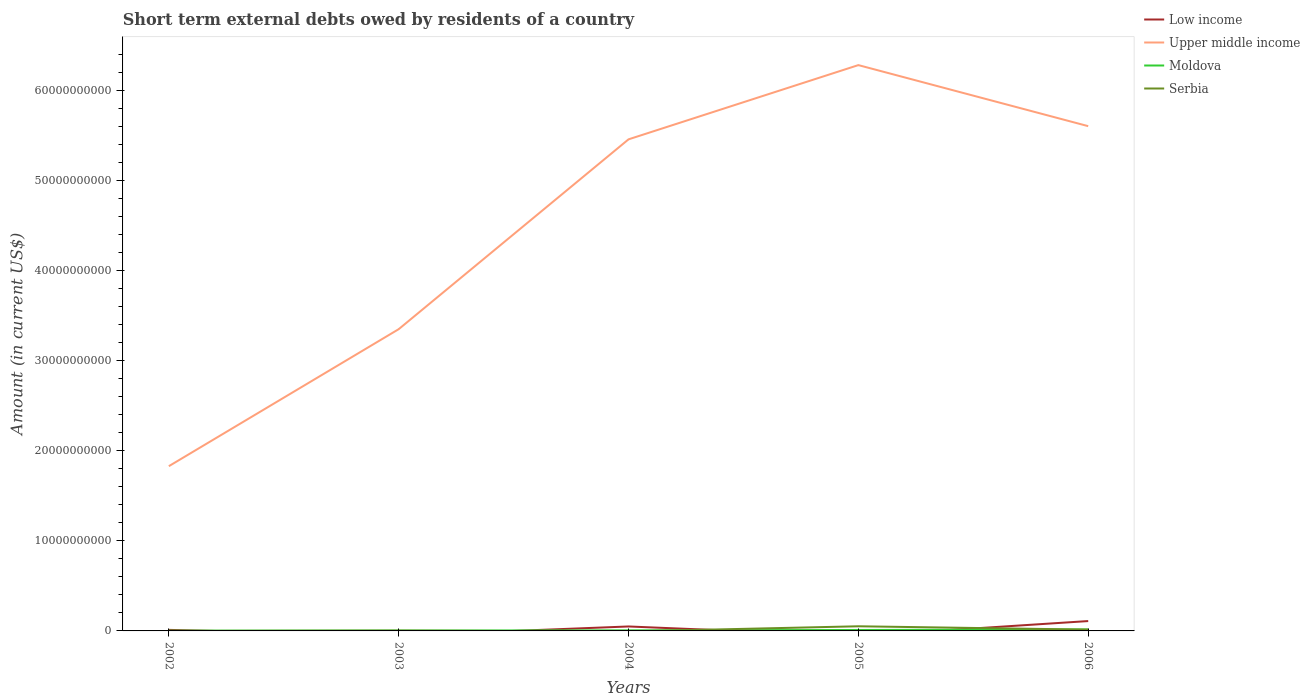How many different coloured lines are there?
Your answer should be compact. 4. Across all years, what is the maximum amount of short-term external debts owed by residents in Low income?
Ensure brevity in your answer.  0. What is the total amount of short-term external debts owed by residents in Low income in the graph?
Keep it short and to the point. -3.78e+08. What is the difference between the highest and the second highest amount of short-term external debts owed by residents in Moldova?
Your answer should be compact. 1.36e+08. What is the difference between the highest and the lowest amount of short-term external debts owed by residents in Moldova?
Give a very brief answer. 2. What is the difference between two consecutive major ticks on the Y-axis?
Your response must be concise. 1.00e+1. How many legend labels are there?
Keep it short and to the point. 4. What is the title of the graph?
Ensure brevity in your answer.  Short term external debts owed by residents of a country. Does "China" appear as one of the legend labels in the graph?
Your response must be concise. No. What is the label or title of the Y-axis?
Your response must be concise. Amount (in current US$). What is the Amount (in current US$) of Low income in 2002?
Ensure brevity in your answer.  1.17e+08. What is the Amount (in current US$) in Upper middle income in 2002?
Keep it short and to the point. 1.83e+1. What is the Amount (in current US$) of Moldova in 2002?
Offer a terse response. 2.94e+07. What is the Amount (in current US$) of Upper middle income in 2003?
Provide a short and direct response. 3.35e+1. What is the Amount (in current US$) in Moldova in 2003?
Give a very brief answer. 4.30e+07. What is the Amount (in current US$) of Serbia in 2003?
Give a very brief answer. 3.55e+07. What is the Amount (in current US$) of Low income in 2004?
Make the answer very short. 4.95e+08. What is the Amount (in current US$) of Upper middle income in 2004?
Give a very brief answer. 5.46e+1. What is the Amount (in current US$) of Moldova in 2004?
Your answer should be compact. 6.33e+07. What is the Amount (in current US$) of Serbia in 2004?
Make the answer very short. 0. What is the Amount (in current US$) of Low income in 2005?
Offer a terse response. 0. What is the Amount (in current US$) of Upper middle income in 2005?
Your response must be concise. 6.28e+1. What is the Amount (in current US$) of Moldova in 2005?
Make the answer very short. 1.04e+08. What is the Amount (in current US$) in Serbia in 2005?
Your response must be concise. 5.15e+08. What is the Amount (in current US$) of Low income in 2006?
Keep it short and to the point. 1.09e+09. What is the Amount (in current US$) of Upper middle income in 2006?
Provide a succinct answer. 5.60e+1. What is the Amount (in current US$) of Moldova in 2006?
Provide a succinct answer. 1.65e+08. What is the Amount (in current US$) in Serbia in 2006?
Provide a short and direct response. 1.43e+08. Across all years, what is the maximum Amount (in current US$) of Low income?
Make the answer very short. 1.09e+09. Across all years, what is the maximum Amount (in current US$) in Upper middle income?
Your answer should be compact. 6.28e+1. Across all years, what is the maximum Amount (in current US$) of Moldova?
Make the answer very short. 1.65e+08. Across all years, what is the maximum Amount (in current US$) of Serbia?
Keep it short and to the point. 5.15e+08. Across all years, what is the minimum Amount (in current US$) of Upper middle income?
Give a very brief answer. 1.83e+1. Across all years, what is the minimum Amount (in current US$) of Moldova?
Provide a succinct answer. 2.94e+07. What is the total Amount (in current US$) of Low income in the graph?
Keep it short and to the point. 1.71e+09. What is the total Amount (in current US$) of Upper middle income in the graph?
Ensure brevity in your answer.  2.25e+11. What is the total Amount (in current US$) in Moldova in the graph?
Offer a terse response. 4.05e+08. What is the total Amount (in current US$) in Serbia in the graph?
Offer a very short reply. 6.94e+08. What is the difference between the Amount (in current US$) of Upper middle income in 2002 and that in 2003?
Offer a very short reply. -1.52e+1. What is the difference between the Amount (in current US$) of Moldova in 2002 and that in 2003?
Your response must be concise. -1.35e+07. What is the difference between the Amount (in current US$) in Low income in 2002 and that in 2004?
Offer a terse response. -3.78e+08. What is the difference between the Amount (in current US$) in Upper middle income in 2002 and that in 2004?
Your answer should be compact. -3.63e+1. What is the difference between the Amount (in current US$) in Moldova in 2002 and that in 2004?
Your answer should be very brief. -3.39e+07. What is the difference between the Amount (in current US$) in Upper middle income in 2002 and that in 2005?
Your response must be concise. -4.45e+1. What is the difference between the Amount (in current US$) of Moldova in 2002 and that in 2005?
Offer a terse response. -7.43e+07. What is the difference between the Amount (in current US$) in Low income in 2002 and that in 2006?
Provide a succinct answer. -9.78e+08. What is the difference between the Amount (in current US$) in Upper middle income in 2002 and that in 2006?
Your answer should be compact. -3.77e+1. What is the difference between the Amount (in current US$) in Moldova in 2002 and that in 2006?
Offer a terse response. -1.36e+08. What is the difference between the Amount (in current US$) in Upper middle income in 2003 and that in 2004?
Your response must be concise. -2.11e+1. What is the difference between the Amount (in current US$) in Moldova in 2003 and that in 2004?
Your response must be concise. -2.04e+07. What is the difference between the Amount (in current US$) of Upper middle income in 2003 and that in 2005?
Provide a succinct answer. -2.93e+1. What is the difference between the Amount (in current US$) in Moldova in 2003 and that in 2005?
Your response must be concise. -6.08e+07. What is the difference between the Amount (in current US$) of Serbia in 2003 and that in 2005?
Make the answer very short. -4.80e+08. What is the difference between the Amount (in current US$) of Upper middle income in 2003 and that in 2006?
Your answer should be very brief. -2.25e+1. What is the difference between the Amount (in current US$) in Moldova in 2003 and that in 2006?
Offer a very short reply. -1.22e+08. What is the difference between the Amount (in current US$) of Serbia in 2003 and that in 2006?
Your answer should be compact. -1.08e+08. What is the difference between the Amount (in current US$) in Upper middle income in 2004 and that in 2005?
Ensure brevity in your answer.  -8.24e+09. What is the difference between the Amount (in current US$) of Moldova in 2004 and that in 2005?
Provide a short and direct response. -4.04e+07. What is the difference between the Amount (in current US$) in Low income in 2004 and that in 2006?
Your response must be concise. -6.00e+08. What is the difference between the Amount (in current US$) in Upper middle income in 2004 and that in 2006?
Provide a succinct answer. -1.46e+09. What is the difference between the Amount (in current US$) in Moldova in 2004 and that in 2006?
Your response must be concise. -1.02e+08. What is the difference between the Amount (in current US$) of Upper middle income in 2005 and that in 2006?
Keep it short and to the point. 6.78e+09. What is the difference between the Amount (in current US$) of Moldova in 2005 and that in 2006?
Offer a very short reply. -6.16e+07. What is the difference between the Amount (in current US$) in Serbia in 2005 and that in 2006?
Provide a short and direct response. 3.72e+08. What is the difference between the Amount (in current US$) in Low income in 2002 and the Amount (in current US$) in Upper middle income in 2003?
Keep it short and to the point. -3.34e+1. What is the difference between the Amount (in current US$) in Low income in 2002 and the Amount (in current US$) in Moldova in 2003?
Your response must be concise. 7.38e+07. What is the difference between the Amount (in current US$) in Low income in 2002 and the Amount (in current US$) in Serbia in 2003?
Offer a very short reply. 8.13e+07. What is the difference between the Amount (in current US$) of Upper middle income in 2002 and the Amount (in current US$) of Moldova in 2003?
Ensure brevity in your answer.  1.82e+1. What is the difference between the Amount (in current US$) in Upper middle income in 2002 and the Amount (in current US$) in Serbia in 2003?
Give a very brief answer. 1.83e+1. What is the difference between the Amount (in current US$) of Moldova in 2002 and the Amount (in current US$) of Serbia in 2003?
Provide a succinct answer. -6.06e+06. What is the difference between the Amount (in current US$) of Low income in 2002 and the Amount (in current US$) of Upper middle income in 2004?
Ensure brevity in your answer.  -5.45e+1. What is the difference between the Amount (in current US$) of Low income in 2002 and the Amount (in current US$) of Moldova in 2004?
Provide a succinct answer. 5.35e+07. What is the difference between the Amount (in current US$) in Upper middle income in 2002 and the Amount (in current US$) in Moldova in 2004?
Your response must be concise. 1.82e+1. What is the difference between the Amount (in current US$) of Low income in 2002 and the Amount (in current US$) of Upper middle income in 2005?
Make the answer very short. -6.27e+1. What is the difference between the Amount (in current US$) of Low income in 2002 and the Amount (in current US$) of Moldova in 2005?
Make the answer very short. 1.30e+07. What is the difference between the Amount (in current US$) of Low income in 2002 and the Amount (in current US$) of Serbia in 2005?
Provide a short and direct response. -3.99e+08. What is the difference between the Amount (in current US$) in Upper middle income in 2002 and the Amount (in current US$) in Moldova in 2005?
Give a very brief answer. 1.82e+1. What is the difference between the Amount (in current US$) of Upper middle income in 2002 and the Amount (in current US$) of Serbia in 2005?
Your answer should be very brief. 1.78e+1. What is the difference between the Amount (in current US$) in Moldova in 2002 and the Amount (in current US$) in Serbia in 2005?
Provide a short and direct response. -4.86e+08. What is the difference between the Amount (in current US$) in Low income in 2002 and the Amount (in current US$) in Upper middle income in 2006?
Offer a very short reply. -5.59e+1. What is the difference between the Amount (in current US$) of Low income in 2002 and the Amount (in current US$) of Moldova in 2006?
Provide a succinct answer. -4.86e+07. What is the difference between the Amount (in current US$) in Low income in 2002 and the Amount (in current US$) in Serbia in 2006?
Make the answer very short. -2.64e+07. What is the difference between the Amount (in current US$) in Upper middle income in 2002 and the Amount (in current US$) in Moldova in 2006?
Your answer should be compact. 1.81e+1. What is the difference between the Amount (in current US$) of Upper middle income in 2002 and the Amount (in current US$) of Serbia in 2006?
Your answer should be very brief. 1.81e+1. What is the difference between the Amount (in current US$) in Moldova in 2002 and the Amount (in current US$) in Serbia in 2006?
Your response must be concise. -1.14e+08. What is the difference between the Amount (in current US$) in Upper middle income in 2003 and the Amount (in current US$) in Moldova in 2004?
Offer a terse response. 3.34e+1. What is the difference between the Amount (in current US$) in Upper middle income in 2003 and the Amount (in current US$) in Moldova in 2005?
Provide a succinct answer. 3.34e+1. What is the difference between the Amount (in current US$) in Upper middle income in 2003 and the Amount (in current US$) in Serbia in 2005?
Your answer should be compact. 3.30e+1. What is the difference between the Amount (in current US$) of Moldova in 2003 and the Amount (in current US$) of Serbia in 2005?
Your answer should be compact. -4.72e+08. What is the difference between the Amount (in current US$) of Upper middle income in 2003 and the Amount (in current US$) of Moldova in 2006?
Offer a terse response. 3.33e+1. What is the difference between the Amount (in current US$) in Upper middle income in 2003 and the Amount (in current US$) in Serbia in 2006?
Provide a short and direct response. 3.34e+1. What is the difference between the Amount (in current US$) of Moldova in 2003 and the Amount (in current US$) of Serbia in 2006?
Give a very brief answer. -1.00e+08. What is the difference between the Amount (in current US$) of Low income in 2004 and the Amount (in current US$) of Upper middle income in 2005?
Your answer should be compact. -6.23e+1. What is the difference between the Amount (in current US$) in Low income in 2004 and the Amount (in current US$) in Moldova in 2005?
Ensure brevity in your answer.  3.91e+08. What is the difference between the Amount (in current US$) in Low income in 2004 and the Amount (in current US$) in Serbia in 2005?
Keep it short and to the point. -2.09e+07. What is the difference between the Amount (in current US$) of Upper middle income in 2004 and the Amount (in current US$) of Moldova in 2005?
Offer a terse response. 5.45e+1. What is the difference between the Amount (in current US$) in Upper middle income in 2004 and the Amount (in current US$) in Serbia in 2005?
Your answer should be very brief. 5.41e+1. What is the difference between the Amount (in current US$) of Moldova in 2004 and the Amount (in current US$) of Serbia in 2005?
Give a very brief answer. -4.52e+08. What is the difference between the Amount (in current US$) of Low income in 2004 and the Amount (in current US$) of Upper middle income in 2006?
Keep it short and to the point. -5.55e+1. What is the difference between the Amount (in current US$) in Low income in 2004 and the Amount (in current US$) in Moldova in 2006?
Your answer should be compact. 3.29e+08. What is the difference between the Amount (in current US$) of Low income in 2004 and the Amount (in current US$) of Serbia in 2006?
Provide a succinct answer. 3.51e+08. What is the difference between the Amount (in current US$) in Upper middle income in 2004 and the Amount (in current US$) in Moldova in 2006?
Ensure brevity in your answer.  5.44e+1. What is the difference between the Amount (in current US$) of Upper middle income in 2004 and the Amount (in current US$) of Serbia in 2006?
Ensure brevity in your answer.  5.44e+1. What is the difference between the Amount (in current US$) in Moldova in 2004 and the Amount (in current US$) in Serbia in 2006?
Offer a terse response. -7.99e+07. What is the difference between the Amount (in current US$) of Upper middle income in 2005 and the Amount (in current US$) of Moldova in 2006?
Keep it short and to the point. 6.26e+1. What is the difference between the Amount (in current US$) in Upper middle income in 2005 and the Amount (in current US$) in Serbia in 2006?
Your answer should be very brief. 6.27e+1. What is the difference between the Amount (in current US$) in Moldova in 2005 and the Amount (in current US$) in Serbia in 2006?
Your answer should be very brief. -3.95e+07. What is the average Amount (in current US$) of Low income per year?
Offer a very short reply. 3.41e+08. What is the average Amount (in current US$) of Upper middle income per year?
Provide a succinct answer. 4.50e+1. What is the average Amount (in current US$) of Moldova per year?
Your answer should be very brief. 8.10e+07. What is the average Amount (in current US$) in Serbia per year?
Your response must be concise. 1.39e+08. In the year 2002, what is the difference between the Amount (in current US$) of Low income and Amount (in current US$) of Upper middle income?
Your answer should be very brief. -1.82e+1. In the year 2002, what is the difference between the Amount (in current US$) of Low income and Amount (in current US$) of Moldova?
Give a very brief answer. 8.73e+07. In the year 2002, what is the difference between the Amount (in current US$) in Upper middle income and Amount (in current US$) in Moldova?
Ensure brevity in your answer.  1.83e+1. In the year 2003, what is the difference between the Amount (in current US$) in Upper middle income and Amount (in current US$) in Moldova?
Make the answer very short. 3.35e+1. In the year 2003, what is the difference between the Amount (in current US$) in Upper middle income and Amount (in current US$) in Serbia?
Your answer should be very brief. 3.35e+1. In the year 2003, what is the difference between the Amount (in current US$) in Moldova and Amount (in current US$) in Serbia?
Offer a terse response. 7.46e+06. In the year 2004, what is the difference between the Amount (in current US$) in Low income and Amount (in current US$) in Upper middle income?
Offer a terse response. -5.41e+1. In the year 2004, what is the difference between the Amount (in current US$) of Low income and Amount (in current US$) of Moldova?
Provide a succinct answer. 4.31e+08. In the year 2004, what is the difference between the Amount (in current US$) in Upper middle income and Amount (in current US$) in Moldova?
Offer a terse response. 5.45e+1. In the year 2005, what is the difference between the Amount (in current US$) of Upper middle income and Amount (in current US$) of Moldova?
Give a very brief answer. 6.27e+1. In the year 2005, what is the difference between the Amount (in current US$) of Upper middle income and Amount (in current US$) of Serbia?
Make the answer very short. 6.23e+1. In the year 2005, what is the difference between the Amount (in current US$) in Moldova and Amount (in current US$) in Serbia?
Ensure brevity in your answer.  -4.12e+08. In the year 2006, what is the difference between the Amount (in current US$) in Low income and Amount (in current US$) in Upper middle income?
Your answer should be compact. -5.49e+1. In the year 2006, what is the difference between the Amount (in current US$) of Low income and Amount (in current US$) of Moldova?
Keep it short and to the point. 9.29e+08. In the year 2006, what is the difference between the Amount (in current US$) in Low income and Amount (in current US$) in Serbia?
Give a very brief answer. 9.52e+08. In the year 2006, what is the difference between the Amount (in current US$) of Upper middle income and Amount (in current US$) of Moldova?
Your answer should be compact. 5.59e+1. In the year 2006, what is the difference between the Amount (in current US$) of Upper middle income and Amount (in current US$) of Serbia?
Offer a very short reply. 5.59e+1. In the year 2006, what is the difference between the Amount (in current US$) of Moldova and Amount (in current US$) of Serbia?
Ensure brevity in your answer.  2.22e+07. What is the ratio of the Amount (in current US$) in Upper middle income in 2002 to that in 2003?
Ensure brevity in your answer.  0.55. What is the ratio of the Amount (in current US$) in Moldova in 2002 to that in 2003?
Keep it short and to the point. 0.69. What is the ratio of the Amount (in current US$) of Low income in 2002 to that in 2004?
Make the answer very short. 0.24. What is the ratio of the Amount (in current US$) in Upper middle income in 2002 to that in 2004?
Provide a succinct answer. 0.34. What is the ratio of the Amount (in current US$) in Moldova in 2002 to that in 2004?
Your answer should be very brief. 0.47. What is the ratio of the Amount (in current US$) in Upper middle income in 2002 to that in 2005?
Your response must be concise. 0.29. What is the ratio of the Amount (in current US$) of Moldova in 2002 to that in 2005?
Give a very brief answer. 0.28. What is the ratio of the Amount (in current US$) in Low income in 2002 to that in 2006?
Your answer should be compact. 0.11. What is the ratio of the Amount (in current US$) in Upper middle income in 2002 to that in 2006?
Offer a terse response. 0.33. What is the ratio of the Amount (in current US$) of Moldova in 2002 to that in 2006?
Your answer should be very brief. 0.18. What is the ratio of the Amount (in current US$) of Upper middle income in 2003 to that in 2004?
Offer a very short reply. 0.61. What is the ratio of the Amount (in current US$) of Moldova in 2003 to that in 2004?
Give a very brief answer. 0.68. What is the ratio of the Amount (in current US$) of Upper middle income in 2003 to that in 2005?
Offer a terse response. 0.53. What is the ratio of the Amount (in current US$) of Moldova in 2003 to that in 2005?
Offer a very short reply. 0.41. What is the ratio of the Amount (in current US$) of Serbia in 2003 to that in 2005?
Ensure brevity in your answer.  0.07. What is the ratio of the Amount (in current US$) in Upper middle income in 2003 to that in 2006?
Your answer should be very brief. 0.6. What is the ratio of the Amount (in current US$) of Moldova in 2003 to that in 2006?
Provide a short and direct response. 0.26. What is the ratio of the Amount (in current US$) in Serbia in 2003 to that in 2006?
Provide a succinct answer. 0.25. What is the ratio of the Amount (in current US$) of Upper middle income in 2004 to that in 2005?
Your answer should be compact. 0.87. What is the ratio of the Amount (in current US$) of Moldova in 2004 to that in 2005?
Provide a short and direct response. 0.61. What is the ratio of the Amount (in current US$) in Low income in 2004 to that in 2006?
Give a very brief answer. 0.45. What is the ratio of the Amount (in current US$) of Upper middle income in 2004 to that in 2006?
Offer a very short reply. 0.97. What is the ratio of the Amount (in current US$) in Moldova in 2004 to that in 2006?
Keep it short and to the point. 0.38. What is the ratio of the Amount (in current US$) of Upper middle income in 2005 to that in 2006?
Make the answer very short. 1.12. What is the ratio of the Amount (in current US$) in Moldova in 2005 to that in 2006?
Keep it short and to the point. 0.63. What is the ratio of the Amount (in current US$) of Serbia in 2005 to that in 2006?
Provide a succinct answer. 3.6. What is the difference between the highest and the second highest Amount (in current US$) of Low income?
Give a very brief answer. 6.00e+08. What is the difference between the highest and the second highest Amount (in current US$) of Upper middle income?
Keep it short and to the point. 6.78e+09. What is the difference between the highest and the second highest Amount (in current US$) in Moldova?
Ensure brevity in your answer.  6.16e+07. What is the difference between the highest and the second highest Amount (in current US$) of Serbia?
Your answer should be very brief. 3.72e+08. What is the difference between the highest and the lowest Amount (in current US$) in Low income?
Offer a terse response. 1.09e+09. What is the difference between the highest and the lowest Amount (in current US$) of Upper middle income?
Keep it short and to the point. 4.45e+1. What is the difference between the highest and the lowest Amount (in current US$) in Moldova?
Make the answer very short. 1.36e+08. What is the difference between the highest and the lowest Amount (in current US$) in Serbia?
Make the answer very short. 5.15e+08. 